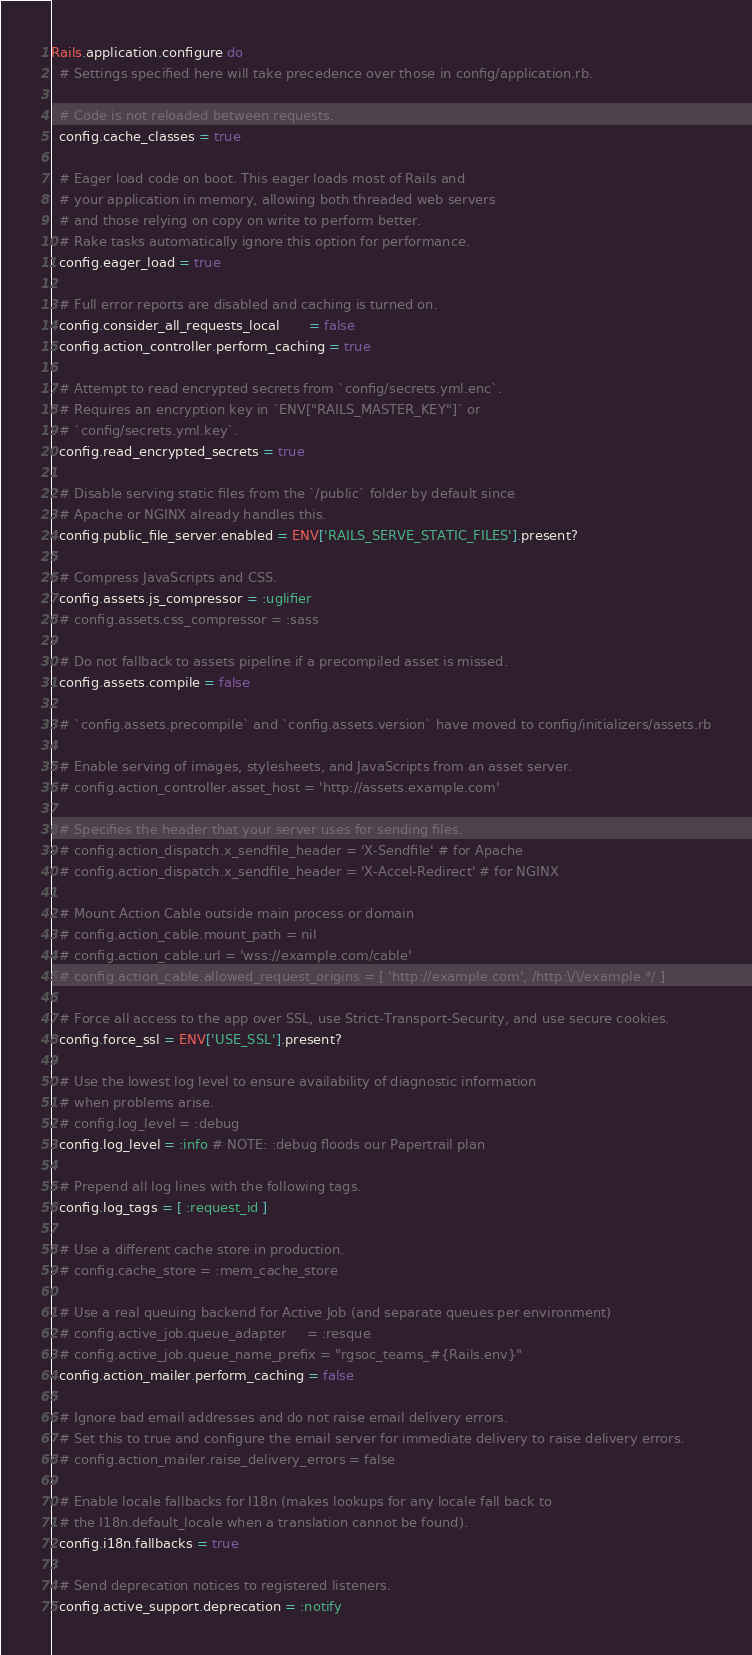Convert code to text. <code><loc_0><loc_0><loc_500><loc_500><_Ruby_>Rails.application.configure do
  # Settings specified here will take precedence over those in config/application.rb.

  # Code is not reloaded between requests.
  config.cache_classes = true

  # Eager load code on boot. This eager loads most of Rails and
  # your application in memory, allowing both threaded web servers
  # and those relying on copy on write to perform better.
  # Rake tasks automatically ignore this option for performance.
  config.eager_load = true

  # Full error reports are disabled and caching is turned on.
  config.consider_all_requests_local       = false
  config.action_controller.perform_caching = true

  # Attempt to read encrypted secrets from `config/secrets.yml.enc`.
  # Requires an encryption key in `ENV["RAILS_MASTER_KEY"]` or
  # `config/secrets.yml.key`.
  config.read_encrypted_secrets = true

  # Disable serving static files from the `/public` folder by default since
  # Apache or NGINX already handles this.
  config.public_file_server.enabled = ENV['RAILS_SERVE_STATIC_FILES'].present?

  # Compress JavaScripts and CSS.
  config.assets.js_compressor = :uglifier
  # config.assets.css_compressor = :sass

  # Do not fallback to assets pipeline if a precompiled asset is missed.
  config.assets.compile = false

  # `config.assets.precompile` and `config.assets.version` have moved to config/initializers/assets.rb

  # Enable serving of images, stylesheets, and JavaScripts from an asset server.
  # config.action_controller.asset_host = 'http://assets.example.com'

  # Specifies the header that your server uses for sending files.
  # config.action_dispatch.x_sendfile_header = 'X-Sendfile' # for Apache
  # config.action_dispatch.x_sendfile_header = 'X-Accel-Redirect' # for NGINX

  # Mount Action Cable outside main process or domain
  # config.action_cable.mount_path = nil
  # config.action_cable.url = 'wss://example.com/cable'
  # config.action_cable.allowed_request_origins = [ 'http://example.com', /http:\/\/example.*/ ]

  # Force all access to the app over SSL, use Strict-Transport-Security, and use secure cookies.
  config.force_ssl = ENV['USE_SSL'].present?

  # Use the lowest log level to ensure availability of diagnostic information
  # when problems arise.
  # config.log_level = :debug
  config.log_level = :info # NOTE: :debug floods our Papertrail plan

  # Prepend all log lines with the following tags.
  config.log_tags = [ :request_id ]

  # Use a different cache store in production.
  # config.cache_store = :mem_cache_store

  # Use a real queuing backend for Active Job (and separate queues per environment)
  # config.active_job.queue_adapter     = :resque
  # config.active_job.queue_name_prefix = "rgsoc_teams_#{Rails.env}"
  config.action_mailer.perform_caching = false

  # Ignore bad email addresses and do not raise email delivery errors.
  # Set this to true and configure the email server for immediate delivery to raise delivery errors.
  # config.action_mailer.raise_delivery_errors = false

  # Enable locale fallbacks for I18n (makes lookups for any locale fall back to
  # the I18n.default_locale when a translation cannot be found).
  config.i18n.fallbacks = true

  # Send deprecation notices to registered listeners.
  config.active_support.deprecation = :notify
</code> 